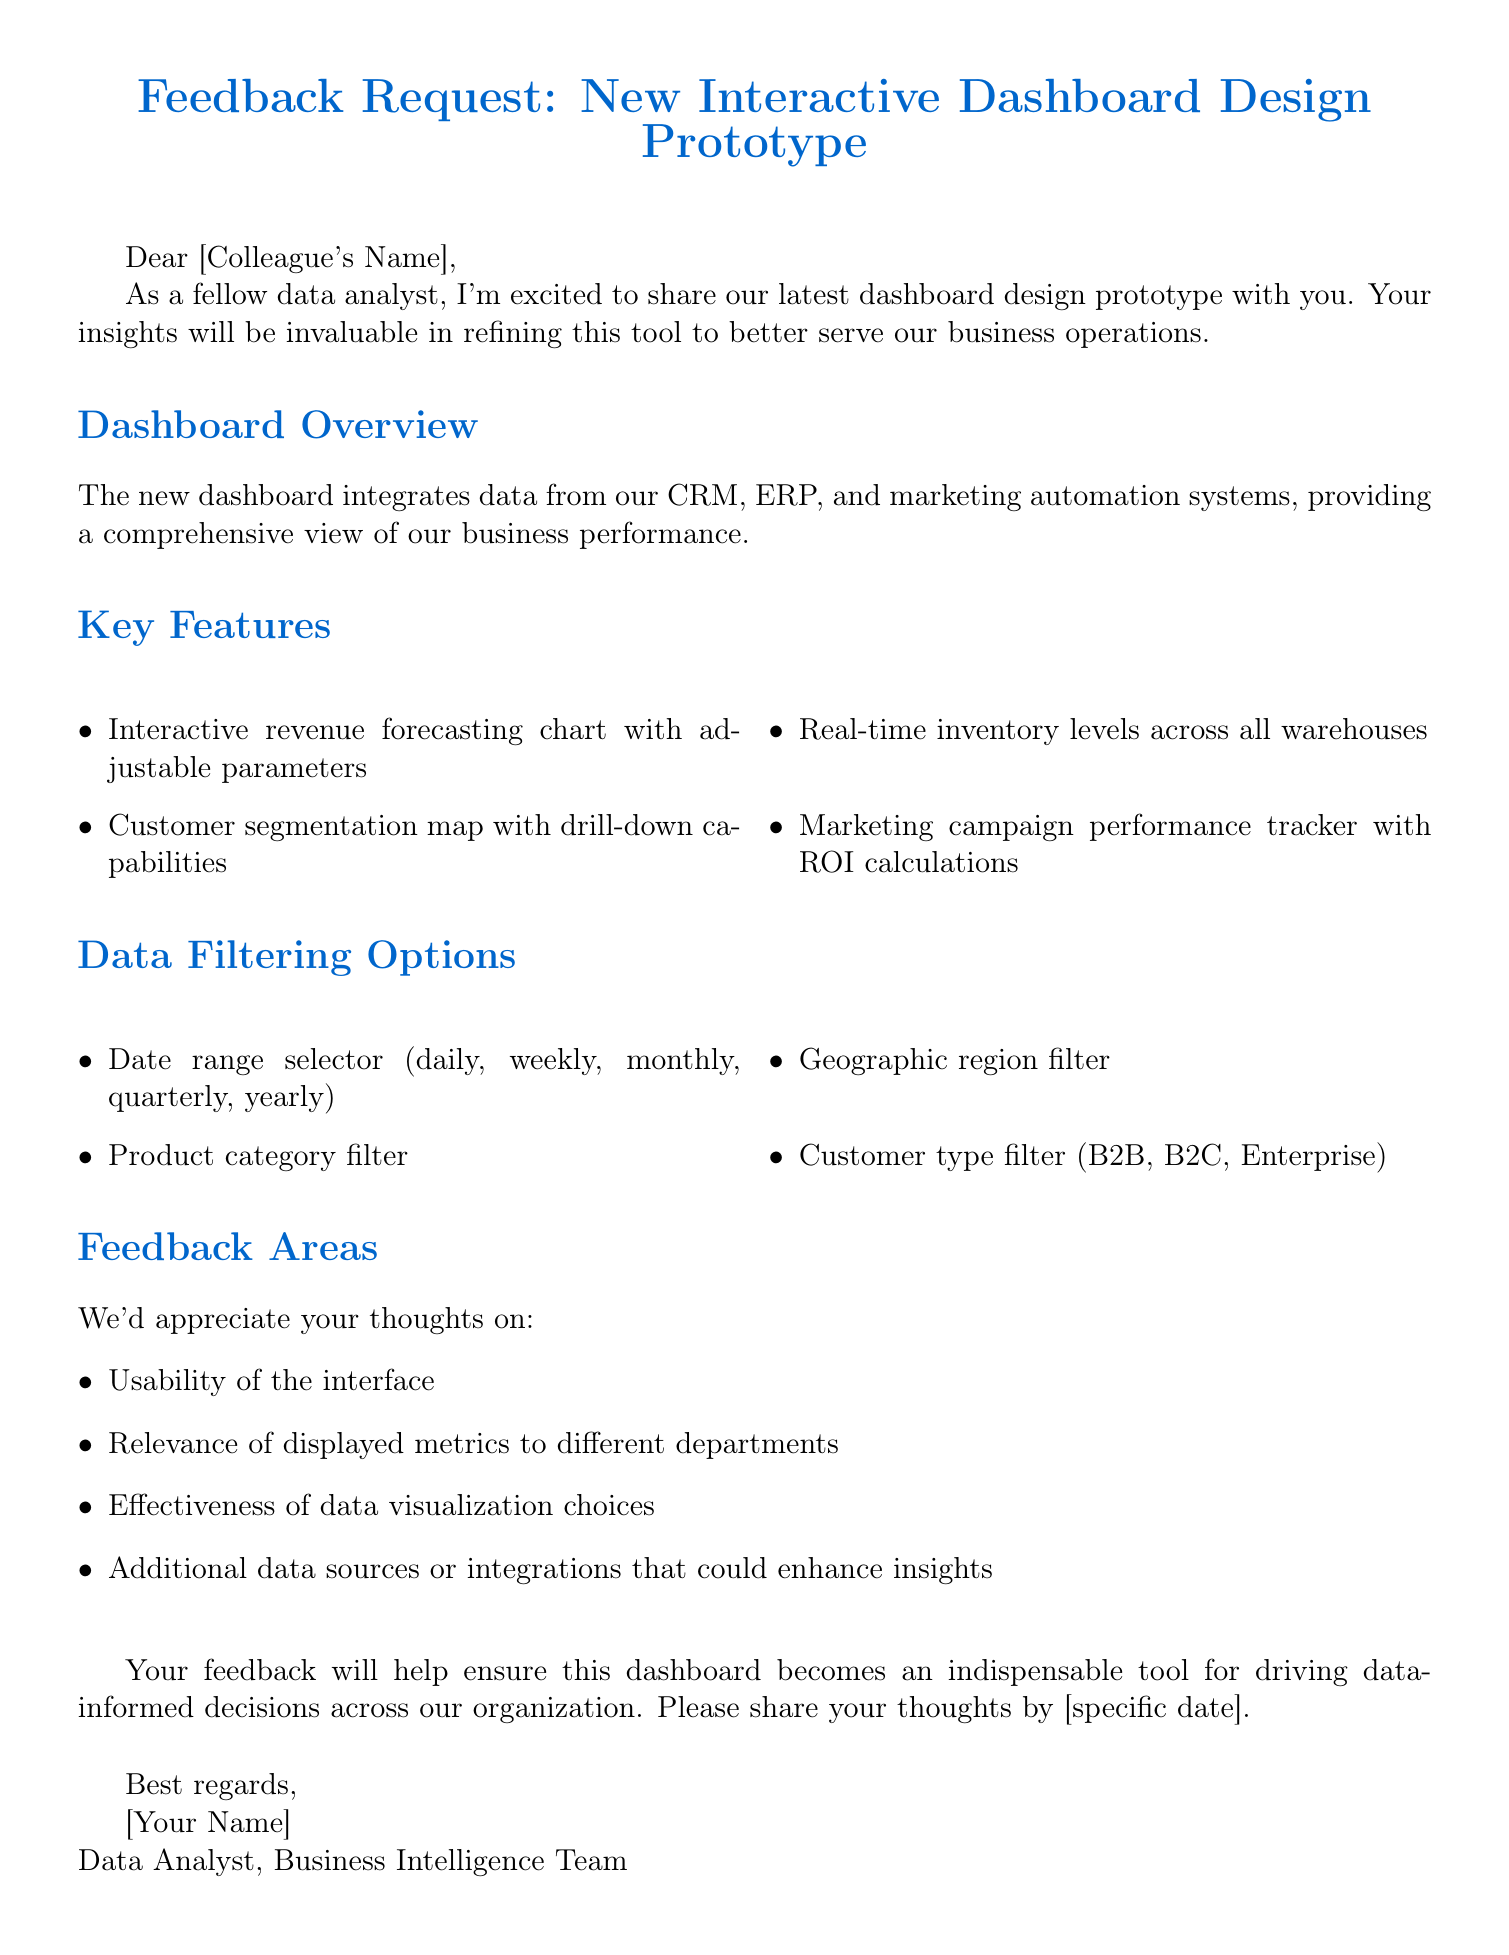What is the subject of the email? The subject of the email is stated at the beginning of the document.
Answer: Feedback Request: New Interactive Dashboard Design Prototype Who is the email addressed to? The salutation indicates that the email is meant for a colleague.
Answer: [Colleague's Name] What are three key features of the dashboard? Key features are listed in a bullet format, naming several aspects of the dashboard.
Answer: Interactive revenue forecasting chart, Customer segmentation map, Real-time inventory levels How many data filtering options are provided? The document lists all the filtering options clearly.
Answer: Four What is one area of feedback requested? The areas of feedback are explicitly listed in the document.
Answer: Usability of the interface When should feedback be shared? The closing section mentions the timeline for sharing feedback.
Answer: [specific date] What department is the sender part of? The signature section provides information about the sender's role.
Answer: Business Intelligence Team 